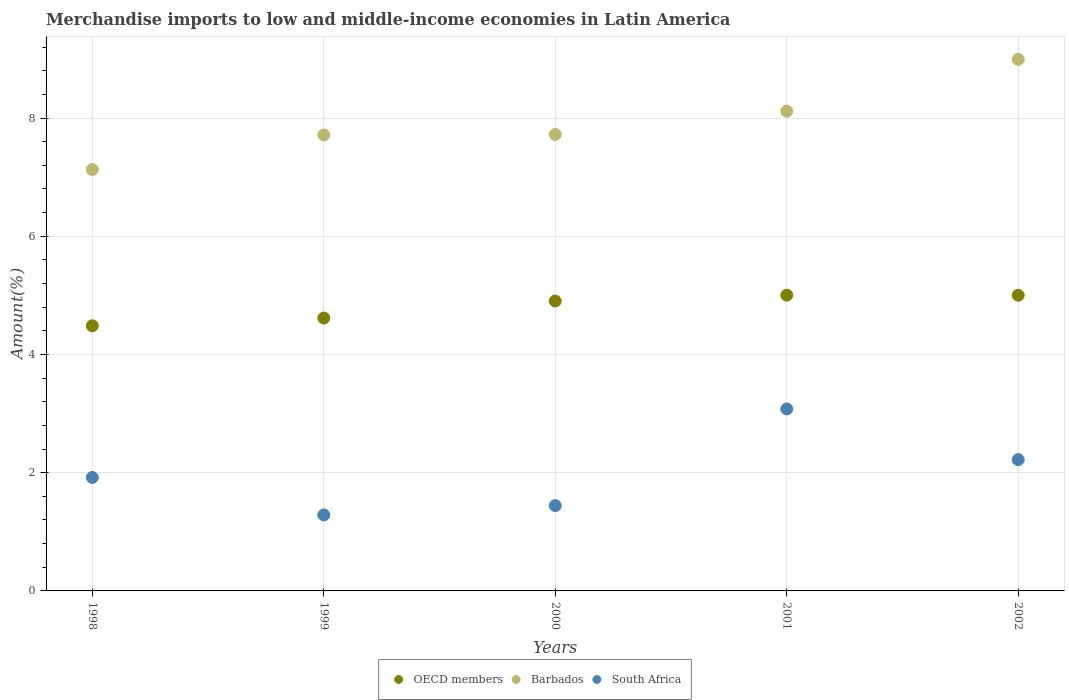What is the percentage of amount earned from merchandise imports in OECD members in 1999?
Keep it short and to the point. 4.62. Across all years, what is the maximum percentage of amount earned from merchandise imports in Barbados?
Your answer should be very brief. 8.99. Across all years, what is the minimum percentage of amount earned from merchandise imports in Barbados?
Provide a short and direct response. 7.13. In which year was the percentage of amount earned from merchandise imports in OECD members maximum?
Provide a short and direct response. 2001. What is the total percentage of amount earned from merchandise imports in OECD members in the graph?
Offer a terse response. 24.01. What is the difference between the percentage of amount earned from merchandise imports in South Africa in 1998 and that in 1999?
Your response must be concise. 0.63. What is the difference between the percentage of amount earned from merchandise imports in Barbados in 2002 and the percentage of amount earned from merchandise imports in South Africa in 1999?
Provide a short and direct response. 7.71. What is the average percentage of amount earned from merchandise imports in South Africa per year?
Provide a short and direct response. 1.99. In the year 1998, what is the difference between the percentage of amount earned from merchandise imports in Barbados and percentage of amount earned from merchandise imports in South Africa?
Your response must be concise. 5.21. What is the ratio of the percentage of amount earned from merchandise imports in Barbados in 2001 to that in 2002?
Keep it short and to the point. 0.9. Is the percentage of amount earned from merchandise imports in OECD members in 2000 less than that in 2001?
Offer a terse response. Yes. What is the difference between the highest and the second highest percentage of amount earned from merchandise imports in South Africa?
Provide a succinct answer. 0.86. What is the difference between the highest and the lowest percentage of amount earned from merchandise imports in Barbados?
Provide a short and direct response. 1.86. Is it the case that in every year, the sum of the percentage of amount earned from merchandise imports in Barbados and percentage of amount earned from merchandise imports in South Africa  is greater than the percentage of amount earned from merchandise imports in OECD members?
Provide a short and direct response. Yes. Is the percentage of amount earned from merchandise imports in Barbados strictly greater than the percentage of amount earned from merchandise imports in OECD members over the years?
Give a very brief answer. Yes. Is the percentage of amount earned from merchandise imports in Barbados strictly less than the percentage of amount earned from merchandise imports in OECD members over the years?
Provide a short and direct response. No. How many years are there in the graph?
Provide a succinct answer. 5. Are the values on the major ticks of Y-axis written in scientific E-notation?
Ensure brevity in your answer.  No. How many legend labels are there?
Make the answer very short. 3. What is the title of the graph?
Your answer should be very brief. Merchandise imports to low and middle-income economies in Latin America. Does "Tonga" appear as one of the legend labels in the graph?
Offer a terse response. No. What is the label or title of the Y-axis?
Keep it short and to the point. Amount(%). What is the Amount(%) of OECD members in 1998?
Ensure brevity in your answer.  4.49. What is the Amount(%) of Barbados in 1998?
Provide a succinct answer. 7.13. What is the Amount(%) of South Africa in 1998?
Keep it short and to the point. 1.92. What is the Amount(%) in OECD members in 1999?
Your answer should be compact. 4.62. What is the Amount(%) of Barbados in 1999?
Give a very brief answer. 7.71. What is the Amount(%) of South Africa in 1999?
Your response must be concise. 1.29. What is the Amount(%) in OECD members in 2000?
Give a very brief answer. 4.9. What is the Amount(%) of Barbados in 2000?
Give a very brief answer. 7.72. What is the Amount(%) in South Africa in 2000?
Give a very brief answer. 1.44. What is the Amount(%) in OECD members in 2001?
Ensure brevity in your answer.  5. What is the Amount(%) of Barbados in 2001?
Make the answer very short. 8.12. What is the Amount(%) in South Africa in 2001?
Your answer should be compact. 3.08. What is the Amount(%) of OECD members in 2002?
Offer a terse response. 5. What is the Amount(%) of Barbados in 2002?
Provide a short and direct response. 8.99. What is the Amount(%) of South Africa in 2002?
Make the answer very short. 2.22. Across all years, what is the maximum Amount(%) in OECD members?
Offer a terse response. 5. Across all years, what is the maximum Amount(%) of Barbados?
Provide a succinct answer. 8.99. Across all years, what is the maximum Amount(%) in South Africa?
Make the answer very short. 3.08. Across all years, what is the minimum Amount(%) in OECD members?
Keep it short and to the point. 4.49. Across all years, what is the minimum Amount(%) of Barbados?
Offer a terse response. 7.13. Across all years, what is the minimum Amount(%) of South Africa?
Ensure brevity in your answer.  1.29. What is the total Amount(%) in OECD members in the graph?
Your response must be concise. 24.01. What is the total Amount(%) in Barbados in the graph?
Keep it short and to the point. 39.67. What is the total Amount(%) in South Africa in the graph?
Provide a succinct answer. 9.95. What is the difference between the Amount(%) of OECD members in 1998 and that in 1999?
Provide a short and direct response. -0.13. What is the difference between the Amount(%) of Barbados in 1998 and that in 1999?
Provide a succinct answer. -0.59. What is the difference between the Amount(%) of South Africa in 1998 and that in 1999?
Make the answer very short. 0.63. What is the difference between the Amount(%) of OECD members in 1998 and that in 2000?
Provide a short and direct response. -0.42. What is the difference between the Amount(%) in Barbados in 1998 and that in 2000?
Provide a succinct answer. -0.59. What is the difference between the Amount(%) of South Africa in 1998 and that in 2000?
Offer a terse response. 0.48. What is the difference between the Amount(%) of OECD members in 1998 and that in 2001?
Offer a terse response. -0.52. What is the difference between the Amount(%) of Barbados in 1998 and that in 2001?
Offer a terse response. -0.99. What is the difference between the Amount(%) in South Africa in 1998 and that in 2001?
Ensure brevity in your answer.  -1.16. What is the difference between the Amount(%) in OECD members in 1998 and that in 2002?
Your answer should be compact. -0.52. What is the difference between the Amount(%) of Barbados in 1998 and that in 2002?
Offer a terse response. -1.86. What is the difference between the Amount(%) in South Africa in 1998 and that in 2002?
Ensure brevity in your answer.  -0.3. What is the difference between the Amount(%) of OECD members in 1999 and that in 2000?
Offer a very short reply. -0.29. What is the difference between the Amount(%) of Barbados in 1999 and that in 2000?
Your answer should be compact. -0.01. What is the difference between the Amount(%) in South Africa in 1999 and that in 2000?
Your answer should be very brief. -0.16. What is the difference between the Amount(%) in OECD members in 1999 and that in 2001?
Offer a very short reply. -0.39. What is the difference between the Amount(%) in Barbados in 1999 and that in 2001?
Provide a succinct answer. -0.4. What is the difference between the Amount(%) of South Africa in 1999 and that in 2001?
Offer a terse response. -1.79. What is the difference between the Amount(%) in OECD members in 1999 and that in 2002?
Make the answer very short. -0.39. What is the difference between the Amount(%) in Barbados in 1999 and that in 2002?
Your answer should be compact. -1.28. What is the difference between the Amount(%) of South Africa in 1999 and that in 2002?
Ensure brevity in your answer.  -0.94. What is the difference between the Amount(%) in Barbados in 2000 and that in 2001?
Provide a succinct answer. -0.39. What is the difference between the Amount(%) of South Africa in 2000 and that in 2001?
Offer a terse response. -1.64. What is the difference between the Amount(%) of OECD members in 2000 and that in 2002?
Keep it short and to the point. -0.1. What is the difference between the Amount(%) in Barbados in 2000 and that in 2002?
Make the answer very short. -1.27. What is the difference between the Amount(%) in South Africa in 2000 and that in 2002?
Offer a very short reply. -0.78. What is the difference between the Amount(%) in OECD members in 2001 and that in 2002?
Offer a very short reply. 0. What is the difference between the Amount(%) in Barbados in 2001 and that in 2002?
Ensure brevity in your answer.  -0.88. What is the difference between the Amount(%) of South Africa in 2001 and that in 2002?
Your response must be concise. 0.86. What is the difference between the Amount(%) in OECD members in 1998 and the Amount(%) in Barbados in 1999?
Offer a terse response. -3.23. What is the difference between the Amount(%) in Barbados in 1998 and the Amount(%) in South Africa in 1999?
Your answer should be compact. 5.84. What is the difference between the Amount(%) in OECD members in 1998 and the Amount(%) in Barbados in 2000?
Your response must be concise. -3.24. What is the difference between the Amount(%) in OECD members in 1998 and the Amount(%) in South Africa in 2000?
Keep it short and to the point. 3.04. What is the difference between the Amount(%) of Barbados in 1998 and the Amount(%) of South Africa in 2000?
Provide a succinct answer. 5.69. What is the difference between the Amount(%) of OECD members in 1998 and the Amount(%) of Barbados in 2001?
Give a very brief answer. -3.63. What is the difference between the Amount(%) in OECD members in 1998 and the Amount(%) in South Africa in 2001?
Give a very brief answer. 1.41. What is the difference between the Amount(%) of Barbados in 1998 and the Amount(%) of South Africa in 2001?
Provide a succinct answer. 4.05. What is the difference between the Amount(%) in OECD members in 1998 and the Amount(%) in Barbados in 2002?
Offer a terse response. -4.51. What is the difference between the Amount(%) in OECD members in 1998 and the Amount(%) in South Africa in 2002?
Your response must be concise. 2.26. What is the difference between the Amount(%) in Barbados in 1998 and the Amount(%) in South Africa in 2002?
Make the answer very short. 4.91. What is the difference between the Amount(%) of OECD members in 1999 and the Amount(%) of Barbados in 2000?
Keep it short and to the point. -3.11. What is the difference between the Amount(%) of OECD members in 1999 and the Amount(%) of South Africa in 2000?
Provide a short and direct response. 3.17. What is the difference between the Amount(%) in Barbados in 1999 and the Amount(%) in South Africa in 2000?
Your answer should be compact. 6.27. What is the difference between the Amount(%) in OECD members in 1999 and the Amount(%) in Barbados in 2001?
Provide a succinct answer. -3.5. What is the difference between the Amount(%) of OECD members in 1999 and the Amount(%) of South Africa in 2001?
Provide a succinct answer. 1.54. What is the difference between the Amount(%) in Barbados in 1999 and the Amount(%) in South Africa in 2001?
Your answer should be very brief. 4.64. What is the difference between the Amount(%) in OECD members in 1999 and the Amount(%) in Barbados in 2002?
Ensure brevity in your answer.  -4.38. What is the difference between the Amount(%) in OECD members in 1999 and the Amount(%) in South Africa in 2002?
Provide a succinct answer. 2.4. What is the difference between the Amount(%) of Barbados in 1999 and the Amount(%) of South Africa in 2002?
Offer a terse response. 5.49. What is the difference between the Amount(%) of OECD members in 2000 and the Amount(%) of Barbados in 2001?
Your answer should be compact. -3.21. What is the difference between the Amount(%) in OECD members in 2000 and the Amount(%) in South Africa in 2001?
Offer a very short reply. 1.83. What is the difference between the Amount(%) in Barbados in 2000 and the Amount(%) in South Africa in 2001?
Make the answer very short. 4.64. What is the difference between the Amount(%) of OECD members in 2000 and the Amount(%) of Barbados in 2002?
Your answer should be compact. -4.09. What is the difference between the Amount(%) in OECD members in 2000 and the Amount(%) in South Africa in 2002?
Ensure brevity in your answer.  2.68. What is the difference between the Amount(%) in Barbados in 2000 and the Amount(%) in South Africa in 2002?
Keep it short and to the point. 5.5. What is the difference between the Amount(%) of OECD members in 2001 and the Amount(%) of Barbados in 2002?
Ensure brevity in your answer.  -3.99. What is the difference between the Amount(%) of OECD members in 2001 and the Amount(%) of South Africa in 2002?
Keep it short and to the point. 2.78. What is the difference between the Amount(%) of Barbados in 2001 and the Amount(%) of South Africa in 2002?
Keep it short and to the point. 5.9. What is the average Amount(%) in OECD members per year?
Provide a succinct answer. 4.8. What is the average Amount(%) of Barbados per year?
Keep it short and to the point. 7.93. What is the average Amount(%) of South Africa per year?
Your response must be concise. 1.99. In the year 1998, what is the difference between the Amount(%) in OECD members and Amount(%) in Barbados?
Make the answer very short. -2.64. In the year 1998, what is the difference between the Amount(%) of OECD members and Amount(%) of South Africa?
Your answer should be very brief. 2.57. In the year 1998, what is the difference between the Amount(%) of Barbados and Amount(%) of South Africa?
Provide a succinct answer. 5.21. In the year 1999, what is the difference between the Amount(%) in OECD members and Amount(%) in Barbados?
Keep it short and to the point. -3.1. In the year 1999, what is the difference between the Amount(%) in OECD members and Amount(%) in South Africa?
Provide a succinct answer. 3.33. In the year 1999, what is the difference between the Amount(%) of Barbados and Amount(%) of South Africa?
Offer a very short reply. 6.43. In the year 2000, what is the difference between the Amount(%) in OECD members and Amount(%) in Barbados?
Provide a short and direct response. -2.82. In the year 2000, what is the difference between the Amount(%) in OECD members and Amount(%) in South Africa?
Offer a terse response. 3.46. In the year 2000, what is the difference between the Amount(%) of Barbados and Amount(%) of South Africa?
Offer a very short reply. 6.28. In the year 2001, what is the difference between the Amount(%) of OECD members and Amount(%) of Barbados?
Keep it short and to the point. -3.11. In the year 2001, what is the difference between the Amount(%) in OECD members and Amount(%) in South Africa?
Provide a succinct answer. 1.93. In the year 2001, what is the difference between the Amount(%) of Barbados and Amount(%) of South Africa?
Provide a short and direct response. 5.04. In the year 2002, what is the difference between the Amount(%) of OECD members and Amount(%) of Barbados?
Keep it short and to the point. -3.99. In the year 2002, what is the difference between the Amount(%) in OECD members and Amount(%) in South Africa?
Offer a terse response. 2.78. In the year 2002, what is the difference between the Amount(%) in Barbados and Amount(%) in South Africa?
Your answer should be very brief. 6.77. What is the ratio of the Amount(%) in OECD members in 1998 to that in 1999?
Provide a succinct answer. 0.97. What is the ratio of the Amount(%) in Barbados in 1998 to that in 1999?
Make the answer very short. 0.92. What is the ratio of the Amount(%) in South Africa in 1998 to that in 1999?
Offer a terse response. 1.49. What is the ratio of the Amount(%) in OECD members in 1998 to that in 2000?
Keep it short and to the point. 0.91. What is the ratio of the Amount(%) in Barbados in 1998 to that in 2000?
Provide a succinct answer. 0.92. What is the ratio of the Amount(%) of South Africa in 1998 to that in 2000?
Your response must be concise. 1.33. What is the ratio of the Amount(%) in OECD members in 1998 to that in 2001?
Your response must be concise. 0.9. What is the ratio of the Amount(%) in Barbados in 1998 to that in 2001?
Keep it short and to the point. 0.88. What is the ratio of the Amount(%) of South Africa in 1998 to that in 2001?
Offer a very short reply. 0.62. What is the ratio of the Amount(%) of OECD members in 1998 to that in 2002?
Offer a terse response. 0.9. What is the ratio of the Amount(%) of Barbados in 1998 to that in 2002?
Give a very brief answer. 0.79. What is the ratio of the Amount(%) of South Africa in 1998 to that in 2002?
Your response must be concise. 0.86. What is the ratio of the Amount(%) in OECD members in 1999 to that in 2000?
Offer a terse response. 0.94. What is the ratio of the Amount(%) in South Africa in 1999 to that in 2000?
Give a very brief answer. 0.89. What is the ratio of the Amount(%) of OECD members in 1999 to that in 2001?
Your response must be concise. 0.92. What is the ratio of the Amount(%) of Barbados in 1999 to that in 2001?
Provide a short and direct response. 0.95. What is the ratio of the Amount(%) in South Africa in 1999 to that in 2001?
Your answer should be very brief. 0.42. What is the ratio of the Amount(%) of OECD members in 1999 to that in 2002?
Provide a short and direct response. 0.92. What is the ratio of the Amount(%) of Barbados in 1999 to that in 2002?
Provide a short and direct response. 0.86. What is the ratio of the Amount(%) in South Africa in 1999 to that in 2002?
Provide a succinct answer. 0.58. What is the ratio of the Amount(%) of OECD members in 2000 to that in 2001?
Offer a terse response. 0.98. What is the ratio of the Amount(%) in Barbados in 2000 to that in 2001?
Offer a terse response. 0.95. What is the ratio of the Amount(%) in South Africa in 2000 to that in 2001?
Make the answer very short. 0.47. What is the ratio of the Amount(%) in OECD members in 2000 to that in 2002?
Keep it short and to the point. 0.98. What is the ratio of the Amount(%) in Barbados in 2000 to that in 2002?
Offer a very short reply. 0.86. What is the ratio of the Amount(%) in South Africa in 2000 to that in 2002?
Keep it short and to the point. 0.65. What is the ratio of the Amount(%) in OECD members in 2001 to that in 2002?
Keep it short and to the point. 1. What is the ratio of the Amount(%) of Barbados in 2001 to that in 2002?
Provide a succinct answer. 0.9. What is the ratio of the Amount(%) in South Africa in 2001 to that in 2002?
Your answer should be compact. 1.39. What is the difference between the highest and the second highest Amount(%) of OECD members?
Offer a very short reply. 0. What is the difference between the highest and the second highest Amount(%) in Barbados?
Keep it short and to the point. 0.88. What is the difference between the highest and the second highest Amount(%) in South Africa?
Provide a short and direct response. 0.86. What is the difference between the highest and the lowest Amount(%) in OECD members?
Make the answer very short. 0.52. What is the difference between the highest and the lowest Amount(%) in Barbados?
Offer a terse response. 1.86. What is the difference between the highest and the lowest Amount(%) of South Africa?
Offer a very short reply. 1.79. 